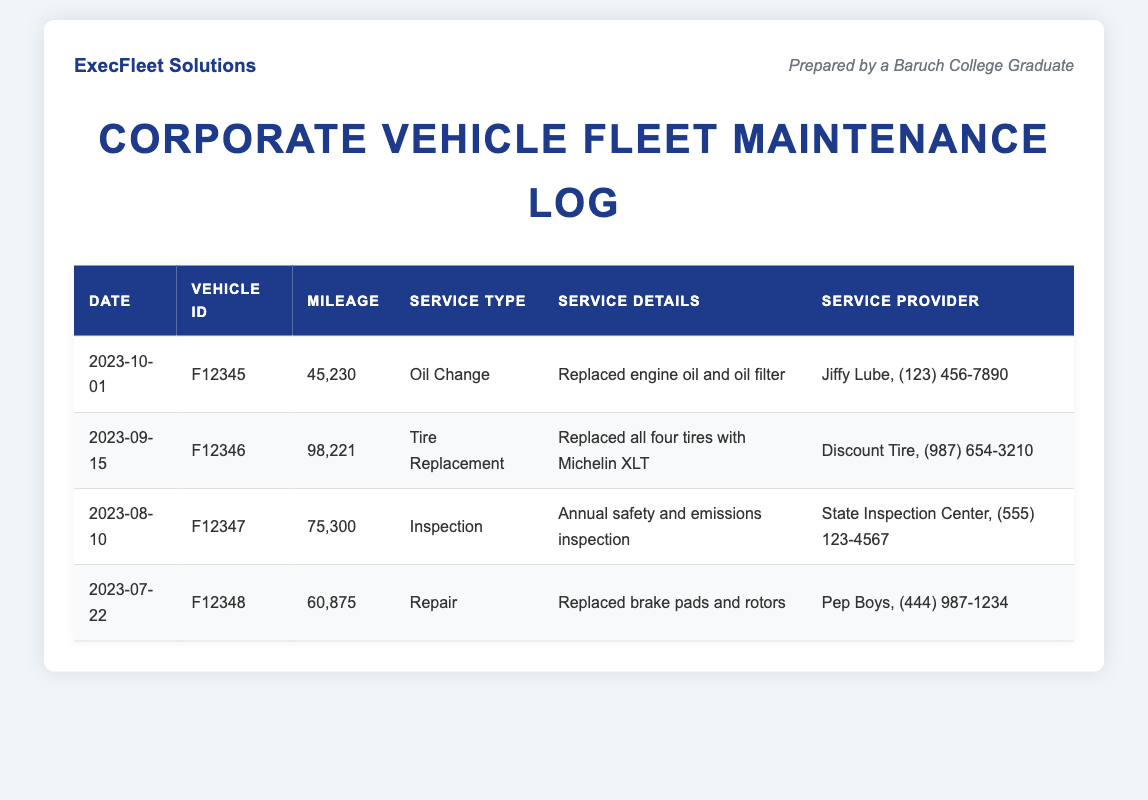What is the date of the last oil change? The last oil change was recorded on 2023-10-01.
Answer: 2023-10-01 What is the vehicle ID for the tire replacement? The tire replacement was for vehicle ID F12346 on 2023-09-15.
Answer: F12346 How many miles did vehicle F12347 have at the time of inspection? Vehicle F12347 had 75,300 miles during the inspection on 2023-08-10.
Answer: 75,300 What service type was performed on July 22, 2023? On July 22, 2023, the service type performed was Repair.
Answer: Repair Who provided the service for the brake pad and rotor replacement? The brake pad and rotor replacement was provided by Pep Boys.
Answer: Pep Boys What service detail was listed for the tire replacement? The service detail listed for the tire replacement is "Replaced all four tires with Michelin XLT."
Answer: Replaced all four tires with Michelin XLT Which vehicle had the highest mileage recorded in this log? The vehicle with the highest mileage in this log was F12346, with 98,221 miles.
Answer: F12346 What was the purpose of the inspection on August 10, 2023? The purpose of the inspection was for annual safety and emissions inspection.
Answer: Annual safety and emissions inspection How many service types are documented in this log? There are four distinct service types documented in this log: Oil Change, Tire Replacement, Inspection, and Repair.
Answer: Four 